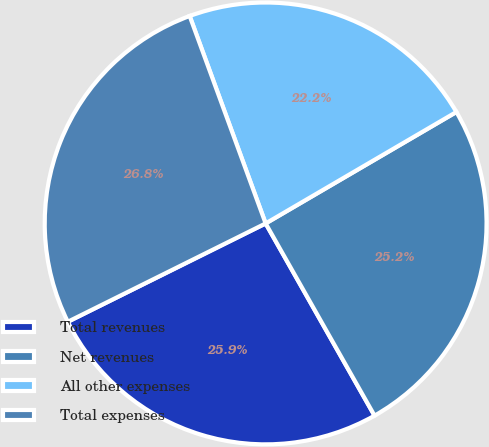Convert chart. <chart><loc_0><loc_0><loc_500><loc_500><pie_chart><fcel>Total revenues<fcel>Net revenues<fcel>All other expenses<fcel>Total expenses<nl><fcel>25.86%<fcel>25.21%<fcel>22.17%<fcel>26.75%<nl></chart> 